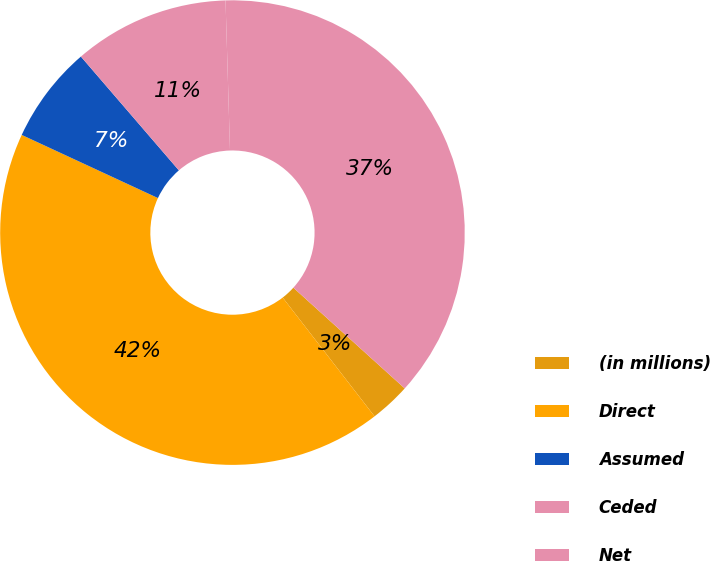<chart> <loc_0><loc_0><loc_500><loc_500><pie_chart><fcel>(in millions)<fcel>Direct<fcel>Assumed<fcel>Ceded<fcel>Net<nl><fcel>2.82%<fcel>42.39%<fcel>6.78%<fcel>10.84%<fcel>37.18%<nl></chart> 